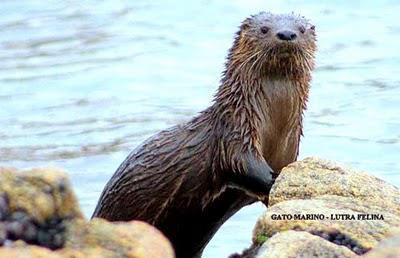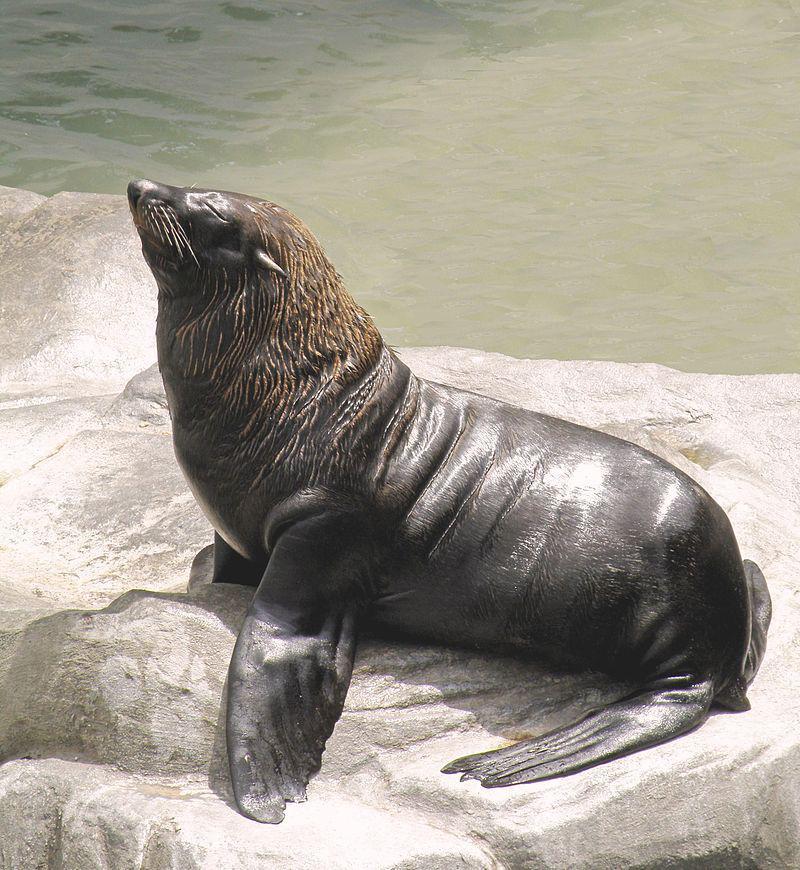The first image is the image on the left, the second image is the image on the right. Given the left and right images, does the statement "Each image contains one aquatic mammal perched on a rock, with upraised head and wet hide, and the animals in the left and right images face different directions." hold true? Answer yes or no. Yes. The first image is the image on the left, the second image is the image on the right. For the images shown, is this caption "An image contains at least two seals." true? Answer yes or no. No. 